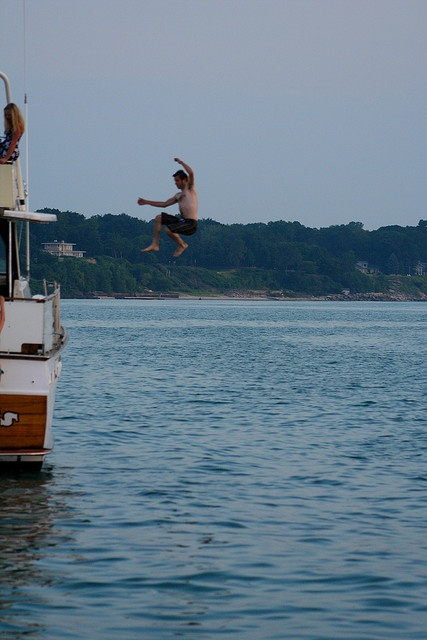Describe the objects in this image and their specific colors. I can see boat in darkgray, black, maroon, and gray tones, people in darkgray, black, maroon, and gray tones, people in darkgray, black, maroon, and gray tones, people in darkgray, gray, and black tones, and people in darkgray, brown, and maroon tones in this image. 